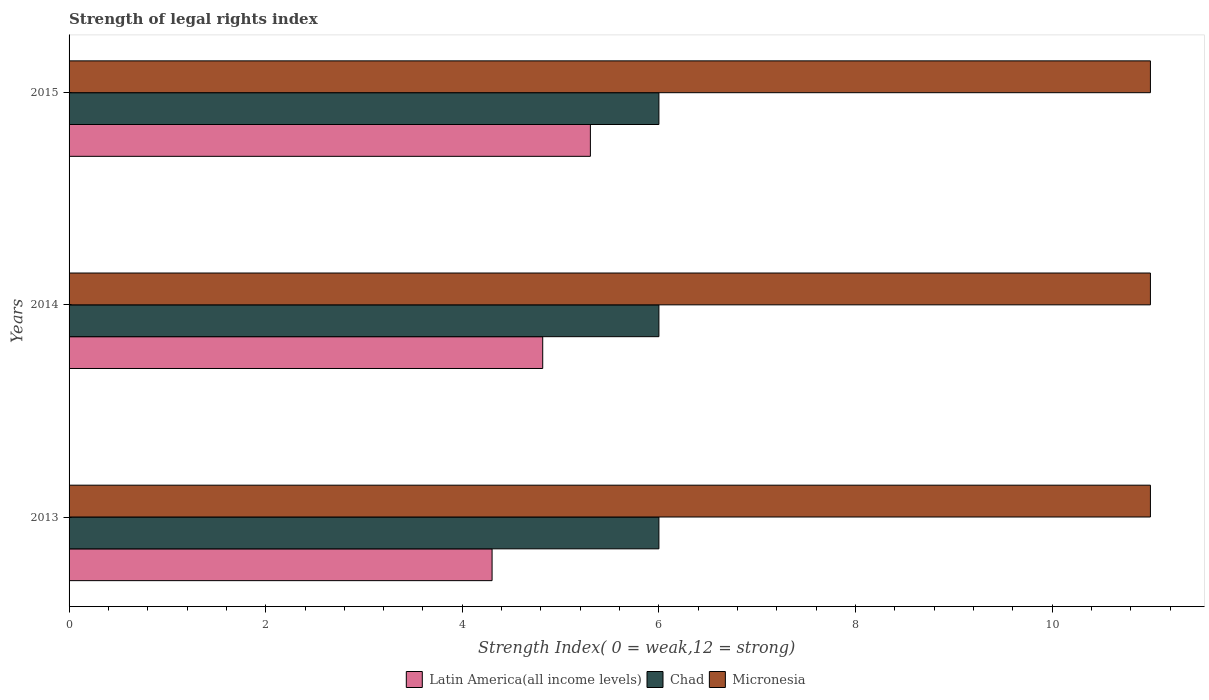How many different coloured bars are there?
Make the answer very short. 3. Are the number of bars per tick equal to the number of legend labels?
Provide a succinct answer. Yes. Are the number of bars on each tick of the Y-axis equal?
Offer a terse response. Yes. How many bars are there on the 2nd tick from the top?
Make the answer very short. 3. How many bars are there on the 2nd tick from the bottom?
Offer a terse response. 3. What is the label of the 3rd group of bars from the top?
Give a very brief answer. 2013. What is the strength index in Micronesia in 2014?
Provide a short and direct response. 11. Across all years, what is the minimum strength index in Chad?
Give a very brief answer. 6. In which year was the strength index in Latin America(all income levels) maximum?
Ensure brevity in your answer.  2015. What is the total strength index in Latin America(all income levels) in the graph?
Your response must be concise. 14.42. What is the difference between the strength index in Chad in 2013 and that in 2015?
Give a very brief answer. 0. What is the difference between the strength index in Latin America(all income levels) in 2014 and the strength index in Micronesia in 2015?
Provide a succinct answer. -6.18. In the year 2014, what is the difference between the strength index in Chad and strength index in Micronesia?
Provide a succinct answer. -5. In how many years, is the strength index in Micronesia greater than 0.8 ?
Offer a very short reply. 3. What is the difference between the highest and the second highest strength index in Latin America(all income levels)?
Offer a terse response. 0.48. In how many years, is the strength index in Micronesia greater than the average strength index in Micronesia taken over all years?
Your answer should be very brief. 0. What does the 2nd bar from the top in 2015 represents?
Offer a terse response. Chad. What does the 3rd bar from the bottom in 2015 represents?
Keep it short and to the point. Micronesia. Is it the case that in every year, the sum of the strength index in Latin America(all income levels) and strength index in Micronesia is greater than the strength index in Chad?
Offer a terse response. Yes. How many years are there in the graph?
Provide a short and direct response. 3. What is the difference between two consecutive major ticks on the X-axis?
Provide a short and direct response. 2. Are the values on the major ticks of X-axis written in scientific E-notation?
Give a very brief answer. No. How many legend labels are there?
Keep it short and to the point. 3. How are the legend labels stacked?
Offer a terse response. Horizontal. What is the title of the graph?
Your answer should be compact. Strength of legal rights index. Does "Hong Kong" appear as one of the legend labels in the graph?
Give a very brief answer. No. What is the label or title of the X-axis?
Keep it short and to the point. Strength Index( 0 = weak,12 = strong). What is the label or title of the Y-axis?
Make the answer very short. Years. What is the Strength Index( 0 = weak,12 = strong) in Latin America(all income levels) in 2013?
Your answer should be very brief. 4.3. What is the Strength Index( 0 = weak,12 = strong) of Chad in 2013?
Offer a very short reply. 6. What is the Strength Index( 0 = weak,12 = strong) in Micronesia in 2013?
Your answer should be very brief. 11. What is the Strength Index( 0 = weak,12 = strong) of Latin America(all income levels) in 2014?
Provide a succinct answer. 4.82. What is the Strength Index( 0 = weak,12 = strong) of Chad in 2014?
Your answer should be compact. 6. What is the Strength Index( 0 = weak,12 = strong) of Micronesia in 2014?
Ensure brevity in your answer.  11. What is the Strength Index( 0 = weak,12 = strong) of Latin America(all income levels) in 2015?
Ensure brevity in your answer.  5.3. What is the Strength Index( 0 = weak,12 = strong) of Micronesia in 2015?
Offer a terse response. 11. Across all years, what is the maximum Strength Index( 0 = weak,12 = strong) of Latin America(all income levels)?
Your answer should be compact. 5.3. Across all years, what is the maximum Strength Index( 0 = weak,12 = strong) in Chad?
Your response must be concise. 6. Across all years, what is the maximum Strength Index( 0 = weak,12 = strong) in Micronesia?
Provide a succinct answer. 11. Across all years, what is the minimum Strength Index( 0 = weak,12 = strong) of Latin America(all income levels)?
Your answer should be compact. 4.3. Across all years, what is the minimum Strength Index( 0 = weak,12 = strong) in Micronesia?
Your response must be concise. 11. What is the total Strength Index( 0 = weak,12 = strong) of Latin America(all income levels) in the graph?
Offer a very short reply. 14.42. What is the difference between the Strength Index( 0 = weak,12 = strong) in Latin America(all income levels) in 2013 and that in 2014?
Ensure brevity in your answer.  -0.52. What is the difference between the Strength Index( 0 = weak,12 = strong) in Chad in 2013 and that in 2014?
Provide a succinct answer. 0. What is the difference between the Strength Index( 0 = weak,12 = strong) in Latin America(all income levels) in 2014 and that in 2015?
Give a very brief answer. -0.48. What is the difference between the Strength Index( 0 = weak,12 = strong) of Chad in 2014 and that in 2015?
Give a very brief answer. 0. What is the difference between the Strength Index( 0 = weak,12 = strong) in Latin America(all income levels) in 2013 and the Strength Index( 0 = weak,12 = strong) in Chad in 2014?
Make the answer very short. -1.7. What is the difference between the Strength Index( 0 = weak,12 = strong) in Latin America(all income levels) in 2013 and the Strength Index( 0 = weak,12 = strong) in Micronesia in 2014?
Keep it short and to the point. -6.7. What is the difference between the Strength Index( 0 = weak,12 = strong) of Latin America(all income levels) in 2013 and the Strength Index( 0 = weak,12 = strong) of Chad in 2015?
Keep it short and to the point. -1.7. What is the difference between the Strength Index( 0 = weak,12 = strong) of Latin America(all income levels) in 2013 and the Strength Index( 0 = weak,12 = strong) of Micronesia in 2015?
Keep it short and to the point. -6.7. What is the difference between the Strength Index( 0 = weak,12 = strong) of Chad in 2013 and the Strength Index( 0 = weak,12 = strong) of Micronesia in 2015?
Provide a succinct answer. -5. What is the difference between the Strength Index( 0 = weak,12 = strong) of Latin America(all income levels) in 2014 and the Strength Index( 0 = weak,12 = strong) of Chad in 2015?
Your response must be concise. -1.18. What is the difference between the Strength Index( 0 = weak,12 = strong) in Latin America(all income levels) in 2014 and the Strength Index( 0 = weak,12 = strong) in Micronesia in 2015?
Your answer should be compact. -6.18. What is the average Strength Index( 0 = weak,12 = strong) of Latin America(all income levels) per year?
Give a very brief answer. 4.81. What is the average Strength Index( 0 = weak,12 = strong) in Chad per year?
Your answer should be very brief. 6. What is the average Strength Index( 0 = weak,12 = strong) in Micronesia per year?
Provide a succinct answer. 11. In the year 2013, what is the difference between the Strength Index( 0 = weak,12 = strong) of Latin America(all income levels) and Strength Index( 0 = weak,12 = strong) of Chad?
Your answer should be very brief. -1.7. In the year 2013, what is the difference between the Strength Index( 0 = weak,12 = strong) of Latin America(all income levels) and Strength Index( 0 = weak,12 = strong) of Micronesia?
Your response must be concise. -6.7. In the year 2013, what is the difference between the Strength Index( 0 = weak,12 = strong) in Chad and Strength Index( 0 = weak,12 = strong) in Micronesia?
Keep it short and to the point. -5. In the year 2014, what is the difference between the Strength Index( 0 = weak,12 = strong) in Latin America(all income levels) and Strength Index( 0 = weak,12 = strong) in Chad?
Offer a terse response. -1.18. In the year 2014, what is the difference between the Strength Index( 0 = weak,12 = strong) of Latin America(all income levels) and Strength Index( 0 = weak,12 = strong) of Micronesia?
Your answer should be compact. -6.18. In the year 2015, what is the difference between the Strength Index( 0 = weak,12 = strong) in Latin America(all income levels) and Strength Index( 0 = weak,12 = strong) in Chad?
Offer a terse response. -0.7. In the year 2015, what is the difference between the Strength Index( 0 = weak,12 = strong) in Latin America(all income levels) and Strength Index( 0 = weak,12 = strong) in Micronesia?
Provide a short and direct response. -5.7. In the year 2015, what is the difference between the Strength Index( 0 = weak,12 = strong) in Chad and Strength Index( 0 = weak,12 = strong) in Micronesia?
Provide a short and direct response. -5. What is the ratio of the Strength Index( 0 = weak,12 = strong) of Latin America(all income levels) in 2013 to that in 2014?
Your response must be concise. 0.89. What is the ratio of the Strength Index( 0 = weak,12 = strong) of Latin America(all income levels) in 2013 to that in 2015?
Provide a succinct answer. 0.81. What is the ratio of the Strength Index( 0 = weak,12 = strong) in Chad in 2013 to that in 2015?
Your response must be concise. 1. What is the ratio of the Strength Index( 0 = weak,12 = strong) in Latin America(all income levels) in 2014 to that in 2015?
Provide a short and direct response. 0.91. What is the difference between the highest and the second highest Strength Index( 0 = weak,12 = strong) of Latin America(all income levels)?
Offer a terse response. 0.48. What is the difference between the highest and the second highest Strength Index( 0 = weak,12 = strong) in Chad?
Provide a succinct answer. 0. What is the difference between the highest and the second highest Strength Index( 0 = weak,12 = strong) of Micronesia?
Your answer should be very brief. 0. What is the difference between the highest and the lowest Strength Index( 0 = weak,12 = strong) in Chad?
Your answer should be compact. 0. 